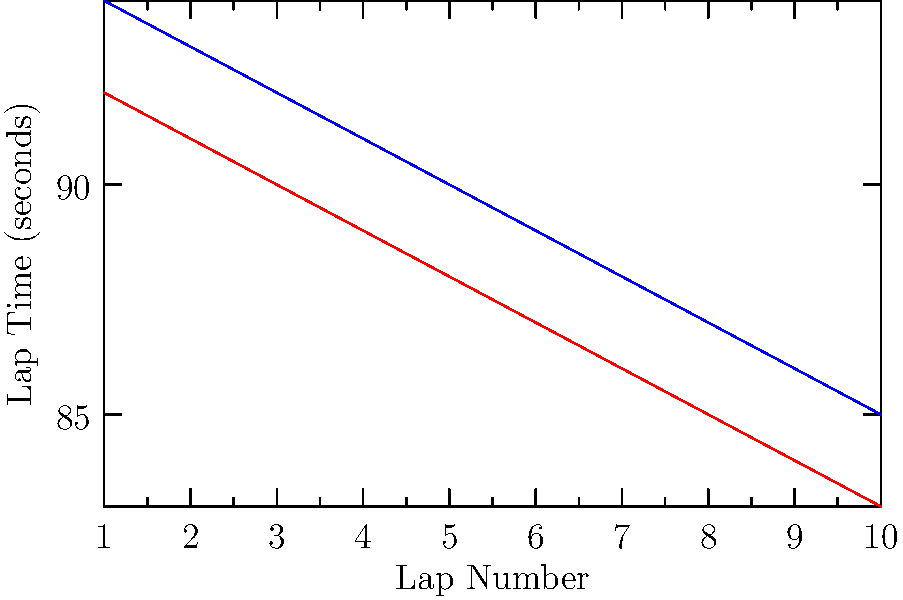Based on the multi-line graph showing lap times and the bar chart displaying fuel efficiency, which driver would be a better choice for recruitment, considering both performance and efficiency? To determine which driver would be a better choice for recruitment, we need to analyze both their performance (lap times) and efficiency (fuel consumption). Let's break down the information from the graphs:

1. Lap Times:
   - Driver A (red line): Starts at 92 seconds and decreases to 83 seconds by lap 10.
   - Driver B (blue line): Starts at 94 seconds and decreases to 85 seconds by lap 10.
   - Driver A consistently has faster lap times throughout the race.

2. Fuel Efficiency:
   - Driver A: 8.2 km/L
   - Driver B: 7.8 km/L
   - Driver A has better fuel efficiency.

3. Performance Analysis:
   - Driver A's lap times are consistently 2 seconds faster than Driver B's.
   - By the 10th lap, Driver A is 2 seconds ahead of Driver B.
   - Driver A shows a steeper improvement curve, indicating better adaptability and potential for growth.

4. Efficiency Analysis:
   - Driver A's fuel efficiency is 0.4 km/L better than Driver B's.
   - This translates to less fuel consumption over the course of a race, which can lead to fewer pit stops and better overall race strategy.

5. Overall Comparison:
   - Driver A outperforms Driver B in both performance and efficiency metrics.
   - The combination of faster lap times and better fuel efficiency suggests that Driver A would be more competitive and cost-effective in races.

Considering both performance and efficiency, Driver A demonstrates superior skills and would be the better choice for recruitment.
Answer: Driver A 